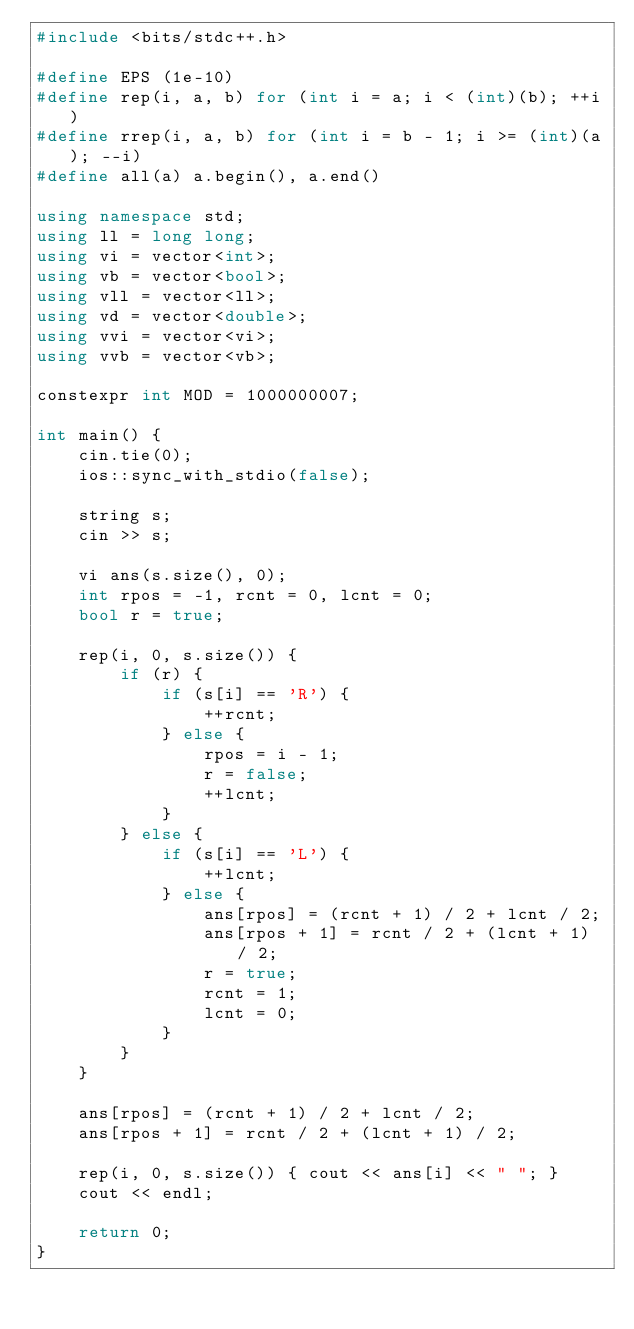<code> <loc_0><loc_0><loc_500><loc_500><_C++_>#include <bits/stdc++.h>

#define EPS (1e-10)
#define rep(i, a, b) for (int i = a; i < (int)(b); ++i)
#define rrep(i, a, b) for (int i = b - 1; i >= (int)(a); --i)
#define all(a) a.begin(), a.end()

using namespace std;
using ll = long long;
using vi = vector<int>;
using vb = vector<bool>;
using vll = vector<ll>;
using vd = vector<double>;
using vvi = vector<vi>;
using vvb = vector<vb>;

constexpr int MOD = 1000000007;

int main() {
    cin.tie(0);
    ios::sync_with_stdio(false);

    string s;
    cin >> s;

    vi ans(s.size(), 0);
    int rpos = -1, rcnt = 0, lcnt = 0;
    bool r = true;

    rep(i, 0, s.size()) {
        if (r) {
            if (s[i] == 'R') {
                ++rcnt;
            } else {
                rpos = i - 1;
                r = false;
                ++lcnt;
            }
        } else {
            if (s[i] == 'L') {
                ++lcnt;
            } else {
                ans[rpos] = (rcnt + 1) / 2 + lcnt / 2;
                ans[rpos + 1] = rcnt / 2 + (lcnt + 1) / 2;
                r = true;
                rcnt = 1;
                lcnt = 0;
            }
        }
    }

    ans[rpos] = (rcnt + 1) / 2 + lcnt / 2;
    ans[rpos + 1] = rcnt / 2 + (lcnt + 1) / 2;

    rep(i, 0, s.size()) { cout << ans[i] << " "; }
    cout << endl;

    return 0;
}</code> 